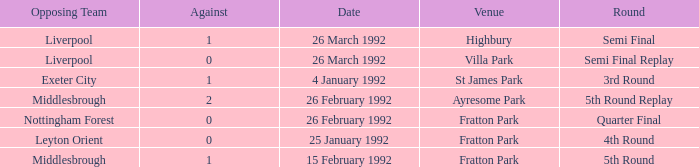What was the stage for villa park? Semi Final Replay. 